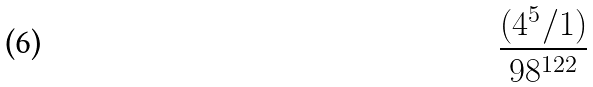<formula> <loc_0><loc_0><loc_500><loc_500>\frac { ( 4 ^ { 5 } / 1 ) } { 9 8 ^ { 1 2 2 } }</formula> 